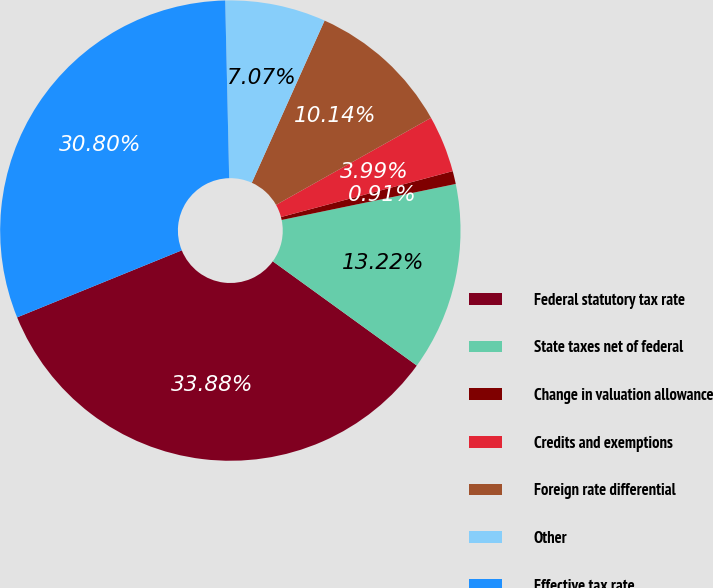Convert chart. <chart><loc_0><loc_0><loc_500><loc_500><pie_chart><fcel>Federal statutory tax rate<fcel>State taxes net of federal<fcel>Change in valuation allowance<fcel>Credits and exemptions<fcel>Foreign rate differential<fcel>Other<fcel>Effective tax rate<nl><fcel>33.88%<fcel>13.22%<fcel>0.91%<fcel>3.99%<fcel>10.14%<fcel>7.07%<fcel>30.8%<nl></chart> 